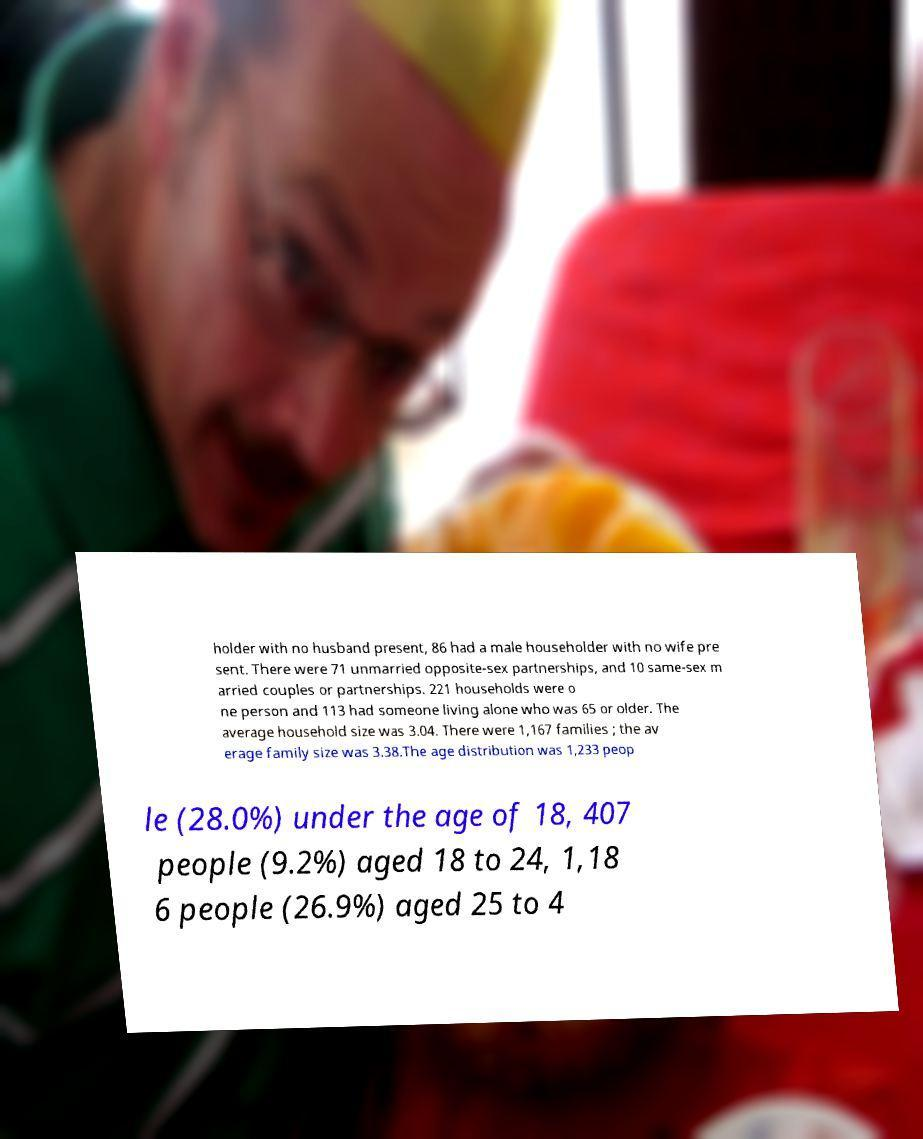For documentation purposes, I need the text within this image transcribed. Could you provide that? holder with no husband present, 86 had a male householder with no wife pre sent. There were 71 unmarried opposite-sex partnerships, and 10 same-sex m arried couples or partnerships. 221 households were o ne person and 113 had someone living alone who was 65 or older. The average household size was 3.04. There were 1,167 families ; the av erage family size was 3.38.The age distribution was 1,233 peop le (28.0%) under the age of 18, 407 people (9.2%) aged 18 to 24, 1,18 6 people (26.9%) aged 25 to 4 